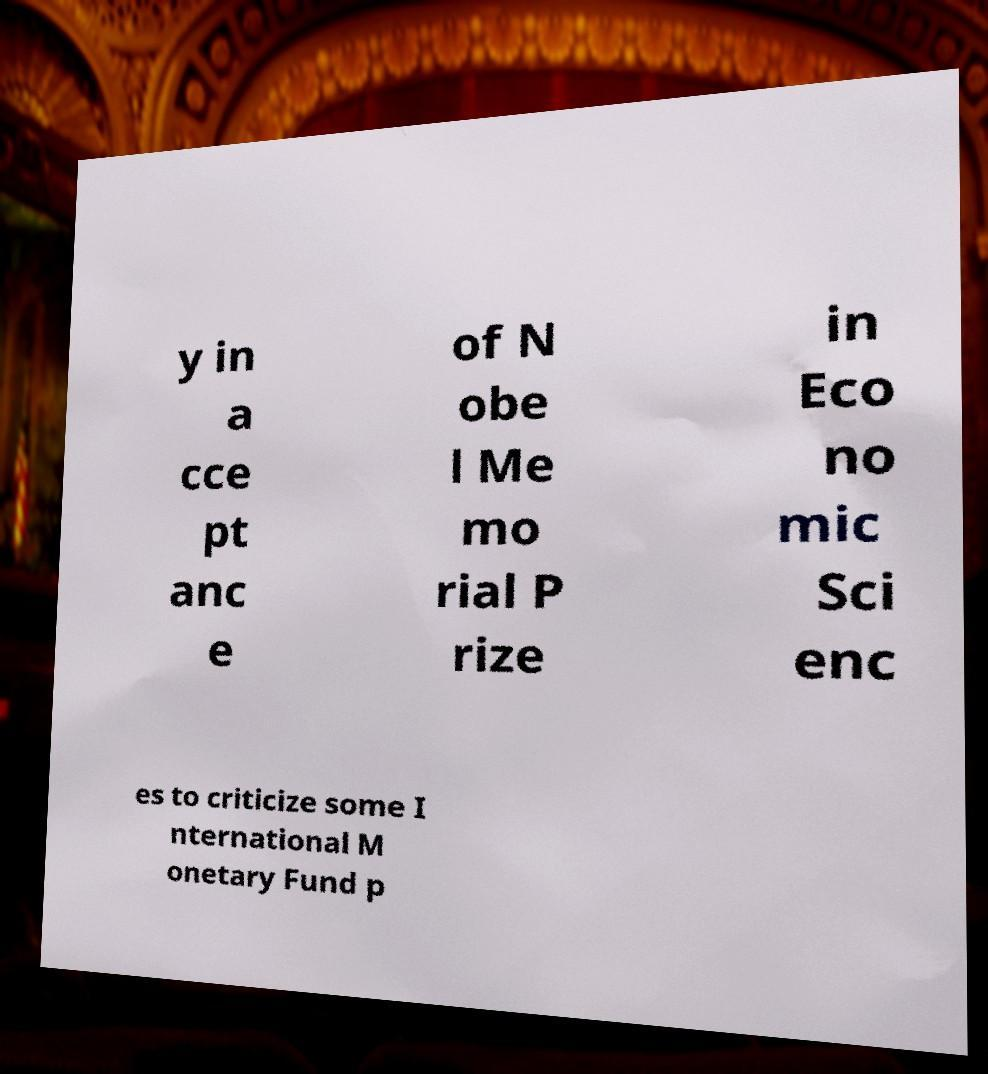Could you extract and type out the text from this image? y in a cce pt anc e of N obe l Me mo rial P rize in Eco no mic Sci enc es to criticize some I nternational M onetary Fund p 